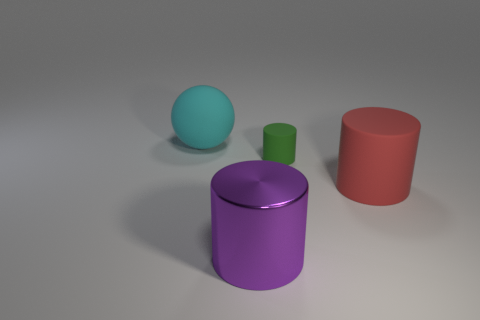Are there any other things that have the same size as the green rubber cylinder?
Provide a short and direct response. No. Are there any other things that are the same material as the purple cylinder?
Ensure brevity in your answer.  No. How many cylinders are on the left side of the big matte thing that is in front of the cyan matte sphere?
Your response must be concise. 2. There is a red object right of the green rubber object; are there any large red objects behind it?
Offer a very short reply. No. There is a small matte cylinder; are there any big purple metal things right of it?
Your answer should be very brief. No. There is a cyan object behind the purple cylinder; is it the same shape as the green thing?
Ensure brevity in your answer.  No. What number of other red matte objects have the same shape as the red rubber object?
Provide a short and direct response. 0. Is there a red block that has the same material as the big sphere?
Provide a succinct answer. No. There is a cylinder that is in front of the matte cylinder to the right of the tiny green rubber object; what is its material?
Ensure brevity in your answer.  Metal. How big is the object that is in front of the big red rubber thing?
Offer a very short reply. Large. 